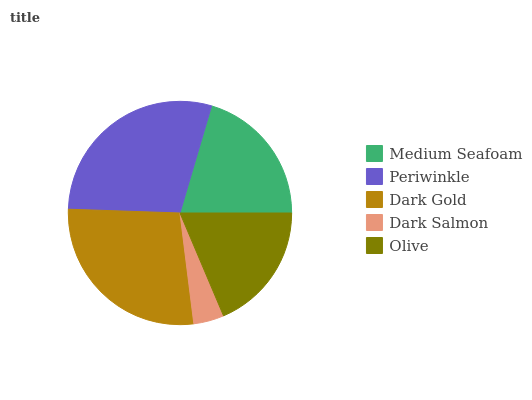Is Dark Salmon the minimum?
Answer yes or no. Yes. Is Periwinkle the maximum?
Answer yes or no. Yes. Is Dark Gold the minimum?
Answer yes or no. No. Is Dark Gold the maximum?
Answer yes or no. No. Is Periwinkle greater than Dark Gold?
Answer yes or no. Yes. Is Dark Gold less than Periwinkle?
Answer yes or no. Yes. Is Dark Gold greater than Periwinkle?
Answer yes or no. No. Is Periwinkle less than Dark Gold?
Answer yes or no. No. Is Medium Seafoam the high median?
Answer yes or no. Yes. Is Medium Seafoam the low median?
Answer yes or no. Yes. Is Olive the high median?
Answer yes or no. No. Is Dark Salmon the low median?
Answer yes or no. No. 